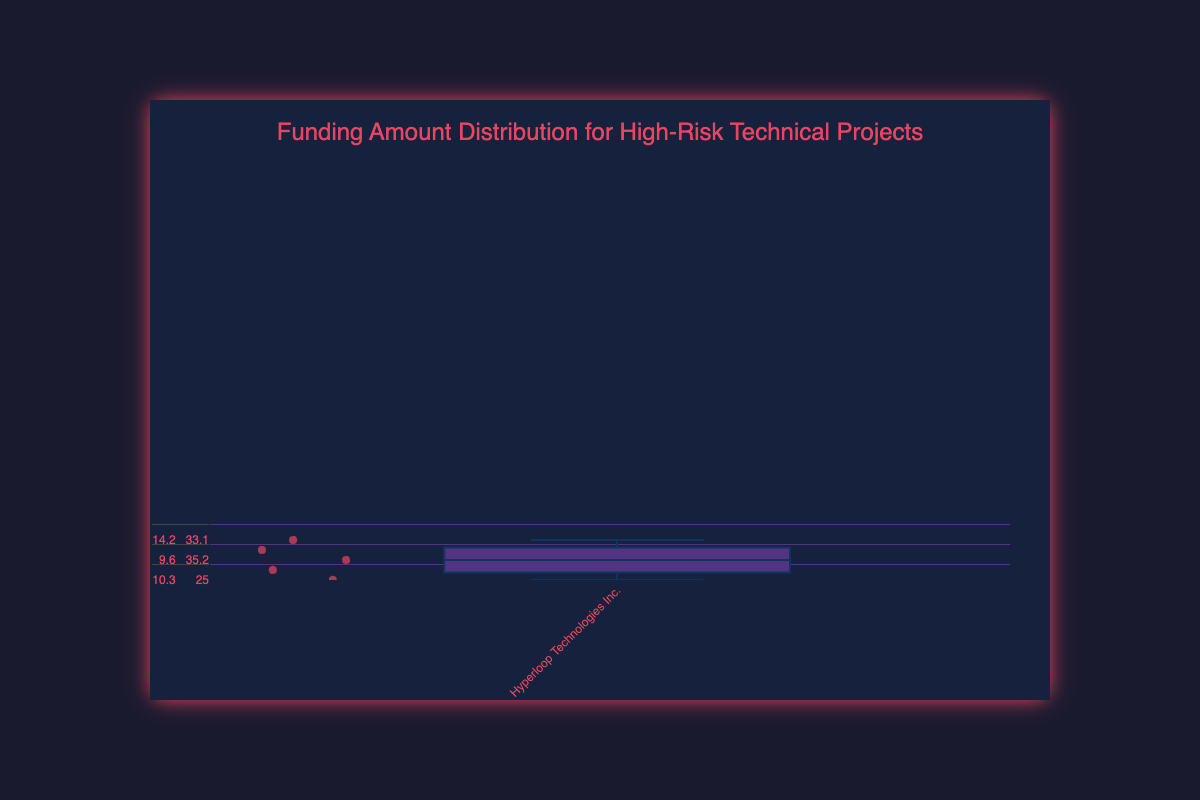What is the title of the figure? The title is located at the top and centered in larger, bold text. It reads "Funding Amount Distribution for High-Risk Technical Projects".
Answer: Funding Amount Distribution for High-Risk Technical Projects How many different project categories are represented in the figure? The x-axis shows the names of different projects, and counting them gives us the total number of categories. Here, projects are: Hyperloop Technologies Inc., Mars Colonization Initiative, Quantum Computing Startups, AI-Driven Healthcare Revolution, Flying Car Development Projects, and Space Tourism Initiatives.
Answer: 6 Which project received the highest median funding amount? The median is depicted by the line inside each box of the box plot. By comparing the medians across the projects, we observe the highest median for the Mars Colonization Initiative.
Answer: Mars Colonization Initiative What is the range of funding amounts for the Flying Car Development Projects? The range can be determined by looking at the minimum and maximum values depicted by the whiskers of the box plot for the Flying Car Development Projects. The lowest value is 5.2 million, and the highest is 8.3 million.
Answer: 5.2 to 8.3 million Which project has the smallest interquartile range (IQR)? The IQR is the distance between the first quartile (Q1) and the third quartile (Q3). By visually comparing the length of the boxes, the smallest IQR appears to be in Quantum Computing Startups.
Answer: Quantum Computing Startups Compare the funding distribution range between Hyperloop Technologies Inc. and Space Tourism Initiatives. Which has the wider range? The range is the difference between the lowest and highest values (whiskers). For Hyperloop Technologies Inc., it ranges from 9.6 to 15.0 (5.4). For Space Tourism Initiatives, it ranges from 12.9 to 16.0 (3.1).
Answer: Hyperloop Technologies Inc What can you infer about the variability of funding in AI-Driven Healthcare Revolution compared to Quantum Computing Startups? Variability can be inferred from the length of the whiskers and the spread of the boxes. AI-Driven Healthcare Revolution has a wider spread in both the box and whiskers compared to Quantum Computing Startups, indicating higher variability.
Answer: Higher variability in AI-Driven Healthcare Revolution Which project has the highest maximum funding amount, and what is the amount? The maximum value is indicated by the top whisker. The highest top whisker is observed for Mars Colonization Initiative, with the amount being 35.2 million.
Answer: Mars Colonization Initiative, 35.2 million Is the funding distribution for any project skewed, and which project shows this most prominently? Skewness can be observed if one whisker is significantly longer than the other or if one side of the box is stretched. The Mars Colonization Initiative displays a longer upper whisker, indicating a skew towards higher values.
Answer: Mars Colonization Initiative What is the median funding amount for Quantum Computing Startups, and why? The median is represented by the line within the box plot. For Quantum Computing Startups, the median line is at about 9.7 million.
Answer: 9.7 million 